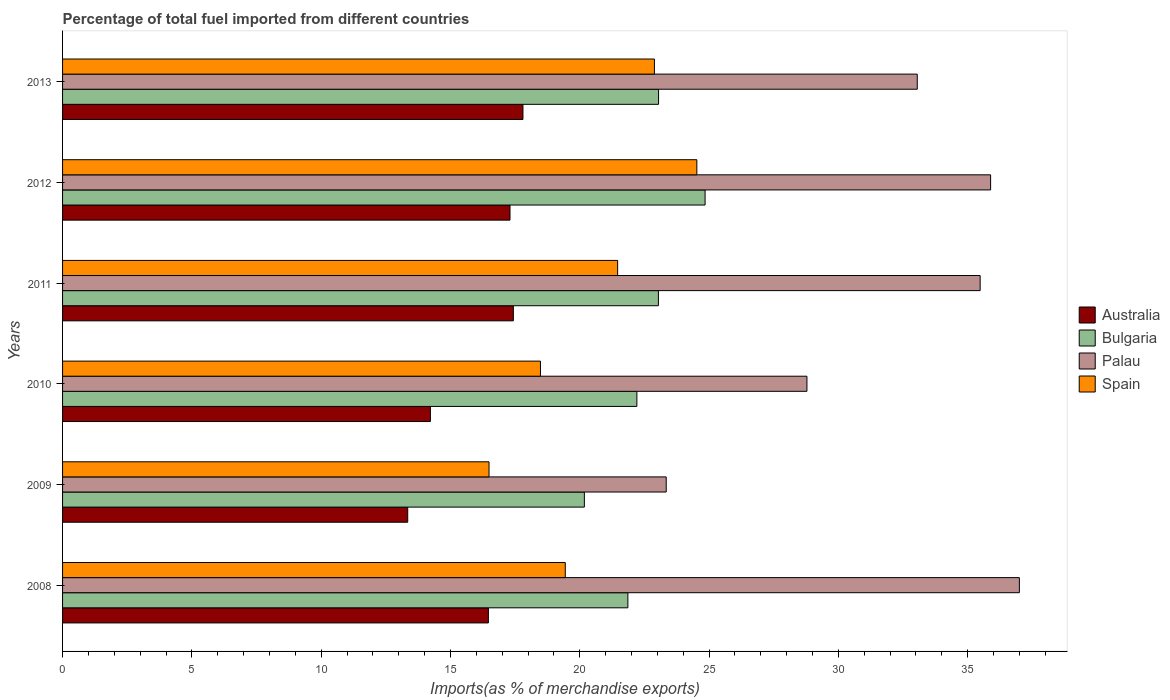Are the number of bars per tick equal to the number of legend labels?
Provide a short and direct response. Yes. Are the number of bars on each tick of the Y-axis equal?
Your response must be concise. Yes. How many bars are there on the 4th tick from the top?
Offer a terse response. 4. What is the percentage of imports to different countries in Spain in 2011?
Your response must be concise. 21.46. Across all years, what is the maximum percentage of imports to different countries in Australia?
Offer a very short reply. 17.8. Across all years, what is the minimum percentage of imports to different countries in Palau?
Offer a terse response. 23.34. In which year was the percentage of imports to different countries in Australia maximum?
Provide a short and direct response. 2013. In which year was the percentage of imports to different countries in Palau minimum?
Provide a succinct answer. 2009. What is the total percentage of imports to different countries in Bulgaria in the graph?
Keep it short and to the point. 135.18. What is the difference between the percentage of imports to different countries in Palau in 2008 and that in 2012?
Offer a very short reply. 1.11. What is the difference between the percentage of imports to different countries in Spain in 2010 and the percentage of imports to different countries in Bulgaria in 2011?
Give a very brief answer. -4.56. What is the average percentage of imports to different countries in Palau per year?
Your answer should be compact. 32.26. In the year 2012, what is the difference between the percentage of imports to different countries in Australia and percentage of imports to different countries in Spain?
Provide a short and direct response. -7.23. What is the ratio of the percentage of imports to different countries in Bulgaria in 2011 to that in 2012?
Provide a succinct answer. 0.93. Is the difference between the percentage of imports to different countries in Australia in 2009 and 2011 greater than the difference between the percentage of imports to different countries in Spain in 2009 and 2011?
Your answer should be very brief. Yes. What is the difference between the highest and the second highest percentage of imports to different countries in Australia?
Keep it short and to the point. 0.37. What is the difference between the highest and the lowest percentage of imports to different countries in Spain?
Offer a terse response. 8.04. In how many years, is the percentage of imports to different countries in Spain greater than the average percentage of imports to different countries in Spain taken over all years?
Offer a terse response. 3. Is the sum of the percentage of imports to different countries in Palau in 2010 and 2011 greater than the maximum percentage of imports to different countries in Bulgaria across all years?
Keep it short and to the point. Yes. Is it the case that in every year, the sum of the percentage of imports to different countries in Bulgaria and percentage of imports to different countries in Spain is greater than the sum of percentage of imports to different countries in Australia and percentage of imports to different countries in Palau?
Keep it short and to the point. No. Is it the case that in every year, the sum of the percentage of imports to different countries in Spain and percentage of imports to different countries in Australia is greater than the percentage of imports to different countries in Palau?
Your answer should be very brief. No. Are all the bars in the graph horizontal?
Make the answer very short. Yes. Are the values on the major ticks of X-axis written in scientific E-notation?
Your response must be concise. No. Where does the legend appear in the graph?
Your response must be concise. Center right. How are the legend labels stacked?
Ensure brevity in your answer.  Vertical. What is the title of the graph?
Your answer should be compact. Percentage of total fuel imported from different countries. Does "Sudan" appear as one of the legend labels in the graph?
Offer a terse response. No. What is the label or title of the X-axis?
Your answer should be compact. Imports(as % of merchandise exports). What is the label or title of the Y-axis?
Your answer should be compact. Years. What is the Imports(as % of merchandise exports) in Australia in 2008?
Keep it short and to the point. 16.47. What is the Imports(as % of merchandise exports) in Bulgaria in 2008?
Provide a succinct answer. 21.86. What is the Imports(as % of merchandise exports) in Palau in 2008?
Your response must be concise. 37. What is the Imports(as % of merchandise exports) in Spain in 2008?
Make the answer very short. 19.44. What is the Imports(as % of merchandise exports) in Australia in 2009?
Your answer should be very brief. 13.35. What is the Imports(as % of merchandise exports) in Bulgaria in 2009?
Offer a very short reply. 20.18. What is the Imports(as % of merchandise exports) of Palau in 2009?
Keep it short and to the point. 23.34. What is the Imports(as % of merchandise exports) in Spain in 2009?
Make the answer very short. 16.49. What is the Imports(as % of merchandise exports) in Australia in 2010?
Offer a very short reply. 14.22. What is the Imports(as % of merchandise exports) in Bulgaria in 2010?
Your answer should be compact. 22.21. What is the Imports(as % of merchandise exports) of Palau in 2010?
Your answer should be very brief. 28.78. What is the Imports(as % of merchandise exports) in Spain in 2010?
Provide a succinct answer. 18.48. What is the Imports(as % of merchandise exports) of Australia in 2011?
Keep it short and to the point. 17.43. What is the Imports(as % of merchandise exports) of Bulgaria in 2011?
Keep it short and to the point. 23.04. What is the Imports(as % of merchandise exports) in Palau in 2011?
Ensure brevity in your answer.  35.48. What is the Imports(as % of merchandise exports) in Spain in 2011?
Offer a terse response. 21.46. What is the Imports(as % of merchandise exports) of Australia in 2012?
Make the answer very short. 17.3. What is the Imports(as % of merchandise exports) in Bulgaria in 2012?
Ensure brevity in your answer.  24.85. What is the Imports(as % of merchandise exports) in Palau in 2012?
Offer a terse response. 35.89. What is the Imports(as % of merchandise exports) in Spain in 2012?
Your response must be concise. 24.53. What is the Imports(as % of merchandise exports) in Australia in 2013?
Provide a succinct answer. 17.8. What is the Imports(as % of merchandise exports) in Bulgaria in 2013?
Ensure brevity in your answer.  23.05. What is the Imports(as % of merchandise exports) in Palau in 2013?
Ensure brevity in your answer.  33.05. What is the Imports(as % of merchandise exports) in Spain in 2013?
Your answer should be very brief. 22.89. Across all years, what is the maximum Imports(as % of merchandise exports) in Australia?
Offer a very short reply. 17.8. Across all years, what is the maximum Imports(as % of merchandise exports) of Bulgaria?
Your response must be concise. 24.85. Across all years, what is the maximum Imports(as % of merchandise exports) in Palau?
Keep it short and to the point. 37. Across all years, what is the maximum Imports(as % of merchandise exports) of Spain?
Your answer should be compact. 24.53. Across all years, what is the minimum Imports(as % of merchandise exports) of Australia?
Give a very brief answer. 13.35. Across all years, what is the minimum Imports(as % of merchandise exports) of Bulgaria?
Make the answer very short. 20.18. Across all years, what is the minimum Imports(as % of merchandise exports) in Palau?
Give a very brief answer. 23.34. Across all years, what is the minimum Imports(as % of merchandise exports) of Spain?
Make the answer very short. 16.49. What is the total Imports(as % of merchandise exports) of Australia in the graph?
Offer a terse response. 96.57. What is the total Imports(as % of merchandise exports) in Bulgaria in the graph?
Your answer should be very brief. 135.18. What is the total Imports(as % of merchandise exports) of Palau in the graph?
Your response must be concise. 193.55. What is the total Imports(as % of merchandise exports) of Spain in the graph?
Offer a terse response. 123.29. What is the difference between the Imports(as % of merchandise exports) in Australia in 2008 and that in 2009?
Ensure brevity in your answer.  3.12. What is the difference between the Imports(as % of merchandise exports) of Bulgaria in 2008 and that in 2009?
Offer a terse response. 1.68. What is the difference between the Imports(as % of merchandise exports) in Palau in 2008 and that in 2009?
Offer a very short reply. 13.66. What is the difference between the Imports(as % of merchandise exports) of Spain in 2008 and that in 2009?
Provide a short and direct response. 2.95. What is the difference between the Imports(as % of merchandise exports) in Australia in 2008 and that in 2010?
Offer a very short reply. 2.24. What is the difference between the Imports(as % of merchandise exports) in Bulgaria in 2008 and that in 2010?
Keep it short and to the point. -0.35. What is the difference between the Imports(as % of merchandise exports) of Palau in 2008 and that in 2010?
Provide a succinct answer. 8.21. What is the difference between the Imports(as % of merchandise exports) in Spain in 2008 and that in 2010?
Keep it short and to the point. 0.96. What is the difference between the Imports(as % of merchandise exports) of Australia in 2008 and that in 2011?
Ensure brevity in your answer.  -0.97. What is the difference between the Imports(as % of merchandise exports) of Bulgaria in 2008 and that in 2011?
Your answer should be very brief. -1.18. What is the difference between the Imports(as % of merchandise exports) in Palau in 2008 and that in 2011?
Your answer should be very brief. 1.52. What is the difference between the Imports(as % of merchandise exports) of Spain in 2008 and that in 2011?
Provide a short and direct response. -2.03. What is the difference between the Imports(as % of merchandise exports) of Australia in 2008 and that in 2012?
Offer a terse response. -0.84. What is the difference between the Imports(as % of merchandise exports) of Bulgaria in 2008 and that in 2012?
Your answer should be very brief. -2.99. What is the difference between the Imports(as % of merchandise exports) in Palau in 2008 and that in 2012?
Offer a very short reply. 1.11. What is the difference between the Imports(as % of merchandise exports) in Spain in 2008 and that in 2012?
Give a very brief answer. -5.09. What is the difference between the Imports(as % of merchandise exports) in Australia in 2008 and that in 2013?
Your answer should be compact. -1.34. What is the difference between the Imports(as % of merchandise exports) of Bulgaria in 2008 and that in 2013?
Give a very brief answer. -1.19. What is the difference between the Imports(as % of merchandise exports) of Palau in 2008 and that in 2013?
Your answer should be very brief. 3.95. What is the difference between the Imports(as % of merchandise exports) of Spain in 2008 and that in 2013?
Your answer should be compact. -3.45. What is the difference between the Imports(as % of merchandise exports) of Australia in 2009 and that in 2010?
Your answer should be compact. -0.88. What is the difference between the Imports(as % of merchandise exports) in Bulgaria in 2009 and that in 2010?
Offer a very short reply. -2.03. What is the difference between the Imports(as % of merchandise exports) in Palau in 2009 and that in 2010?
Provide a short and direct response. -5.44. What is the difference between the Imports(as % of merchandise exports) of Spain in 2009 and that in 2010?
Offer a very short reply. -1.99. What is the difference between the Imports(as % of merchandise exports) in Australia in 2009 and that in 2011?
Offer a terse response. -4.09. What is the difference between the Imports(as % of merchandise exports) of Bulgaria in 2009 and that in 2011?
Offer a terse response. -2.86. What is the difference between the Imports(as % of merchandise exports) in Palau in 2009 and that in 2011?
Provide a succinct answer. -12.14. What is the difference between the Imports(as % of merchandise exports) of Spain in 2009 and that in 2011?
Provide a succinct answer. -4.97. What is the difference between the Imports(as % of merchandise exports) in Australia in 2009 and that in 2012?
Offer a terse response. -3.96. What is the difference between the Imports(as % of merchandise exports) of Bulgaria in 2009 and that in 2012?
Offer a very short reply. -4.67. What is the difference between the Imports(as % of merchandise exports) in Palau in 2009 and that in 2012?
Offer a terse response. -12.54. What is the difference between the Imports(as % of merchandise exports) of Spain in 2009 and that in 2012?
Keep it short and to the point. -8.04. What is the difference between the Imports(as % of merchandise exports) in Australia in 2009 and that in 2013?
Provide a short and direct response. -4.46. What is the difference between the Imports(as % of merchandise exports) in Bulgaria in 2009 and that in 2013?
Your answer should be very brief. -2.87. What is the difference between the Imports(as % of merchandise exports) in Palau in 2009 and that in 2013?
Keep it short and to the point. -9.71. What is the difference between the Imports(as % of merchandise exports) of Spain in 2009 and that in 2013?
Your response must be concise. -6.4. What is the difference between the Imports(as % of merchandise exports) of Australia in 2010 and that in 2011?
Your answer should be very brief. -3.21. What is the difference between the Imports(as % of merchandise exports) of Bulgaria in 2010 and that in 2011?
Your answer should be compact. -0.83. What is the difference between the Imports(as % of merchandise exports) in Palau in 2010 and that in 2011?
Keep it short and to the point. -6.7. What is the difference between the Imports(as % of merchandise exports) of Spain in 2010 and that in 2011?
Your answer should be compact. -2.98. What is the difference between the Imports(as % of merchandise exports) in Australia in 2010 and that in 2012?
Keep it short and to the point. -3.08. What is the difference between the Imports(as % of merchandise exports) in Bulgaria in 2010 and that in 2012?
Provide a succinct answer. -2.64. What is the difference between the Imports(as % of merchandise exports) in Palau in 2010 and that in 2012?
Your response must be concise. -7.1. What is the difference between the Imports(as % of merchandise exports) in Spain in 2010 and that in 2012?
Ensure brevity in your answer.  -6.05. What is the difference between the Imports(as % of merchandise exports) of Australia in 2010 and that in 2013?
Your response must be concise. -3.58. What is the difference between the Imports(as % of merchandise exports) in Bulgaria in 2010 and that in 2013?
Your answer should be compact. -0.84. What is the difference between the Imports(as % of merchandise exports) of Palau in 2010 and that in 2013?
Offer a terse response. -4.27. What is the difference between the Imports(as % of merchandise exports) in Spain in 2010 and that in 2013?
Keep it short and to the point. -4.41. What is the difference between the Imports(as % of merchandise exports) in Australia in 2011 and that in 2012?
Keep it short and to the point. 0.13. What is the difference between the Imports(as % of merchandise exports) in Bulgaria in 2011 and that in 2012?
Provide a short and direct response. -1.81. What is the difference between the Imports(as % of merchandise exports) in Palau in 2011 and that in 2012?
Give a very brief answer. -0.4. What is the difference between the Imports(as % of merchandise exports) in Spain in 2011 and that in 2012?
Your answer should be very brief. -3.06. What is the difference between the Imports(as % of merchandise exports) of Australia in 2011 and that in 2013?
Keep it short and to the point. -0.37. What is the difference between the Imports(as % of merchandise exports) in Bulgaria in 2011 and that in 2013?
Your answer should be very brief. -0.01. What is the difference between the Imports(as % of merchandise exports) of Palau in 2011 and that in 2013?
Provide a short and direct response. 2.43. What is the difference between the Imports(as % of merchandise exports) in Spain in 2011 and that in 2013?
Give a very brief answer. -1.42. What is the difference between the Imports(as % of merchandise exports) in Australia in 2012 and that in 2013?
Provide a succinct answer. -0.5. What is the difference between the Imports(as % of merchandise exports) of Bulgaria in 2012 and that in 2013?
Give a very brief answer. 1.8. What is the difference between the Imports(as % of merchandise exports) in Palau in 2012 and that in 2013?
Keep it short and to the point. 2.84. What is the difference between the Imports(as % of merchandise exports) in Spain in 2012 and that in 2013?
Ensure brevity in your answer.  1.64. What is the difference between the Imports(as % of merchandise exports) of Australia in 2008 and the Imports(as % of merchandise exports) of Bulgaria in 2009?
Provide a succinct answer. -3.71. What is the difference between the Imports(as % of merchandise exports) of Australia in 2008 and the Imports(as % of merchandise exports) of Palau in 2009?
Ensure brevity in your answer.  -6.88. What is the difference between the Imports(as % of merchandise exports) of Australia in 2008 and the Imports(as % of merchandise exports) of Spain in 2009?
Your answer should be very brief. -0.02. What is the difference between the Imports(as % of merchandise exports) in Bulgaria in 2008 and the Imports(as % of merchandise exports) in Palau in 2009?
Offer a terse response. -1.48. What is the difference between the Imports(as % of merchandise exports) of Bulgaria in 2008 and the Imports(as % of merchandise exports) of Spain in 2009?
Make the answer very short. 5.37. What is the difference between the Imports(as % of merchandise exports) in Palau in 2008 and the Imports(as % of merchandise exports) in Spain in 2009?
Your answer should be compact. 20.51. What is the difference between the Imports(as % of merchandise exports) in Australia in 2008 and the Imports(as % of merchandise exports) in Bulgaria in 2010?
Make the answer very short. -5.74. What is the difference between the Imports(as % of merchandise exports) in Australia in 2008 and the Imports(as % of merchandise exports) in Palau in 2010?
Ensure brevity in your answer.  -12.32. What is the difference between the Imports(as % of merchandise exports) of Australia in 2008 and the Imports(as % of merchandise exports) of Spain in 2010?
Your response must be concise. -2.01. What is the difference between the Imports(as % of merchandise exports) of Bulgaria in 2008 and the Imports(as % of merchandise exports) of Palau in 2010?
Your answer should be very brief. -6.92. What is the difference between the Imports(as % of merchandise exports) in Bulgaria in 2008 and the Imports(as % of merchandise exports) in Spain in 2010?
Offer a terse response. 3.38. What is the difference between the Imports(as % of merchandise exports) in Palau in 2008 and the Imports(as % of merchandise exports) in Spain in 2010?
Your answer should be compact. 18.52. What is the difference between the Imports(as % of merchandise exports) in Australia in 2008 and the Imports(as % of merchandise exports) in Bulgaria in 2011?
Offer a terse response. -6.57. What is the difference between the Imports(as % of merchandise exports) of Australia in 2008 and the Imports(as % of merchandise exports) of Palau in 2011?
Make the answer very short. -19.02. What is the difference between the Imports(as % of merchandise exports) in Australia in 2008 and the Imports(as % of merchandise exports) in Spain in 2011?
Give a very brief answer. -5. What is the difference between the Imports(as % of merchandise exports) in Bulgaria in 2008 and the Imports(as % of merchandise exports) in Palau in 2011?
Give a very brief answer. -13.62. What is the difference between the Imports(as % of merchandise exports) in Bulgaria in 2008 and the Imports(as % of merchandise exports) in Spain in 2011?
Keep it short and to the point. 0.4. What is the difference between the Imports(as % of merchandise exports) in Palau in 2008 and the Imports(as % of merchandise exports) in Spain in 2011?
Your response must be concise. 15.53. What is the difference between the Imports(as % of merchandise exports) in Australia in 2008 and the Imports(as % of merchandise exports) in Bulgaria in 2012?
Your answer should be compact. -8.38. What is the difference between the Imports(as % of merchandise exports) in Australia in 2008 and the Imports(as % of merchandise exports) in Palau in 2012?
Your answer should be compact. -19.42. What is the difference between the Imports(as % of merchandise exports) in Australia in 2008 and the Imports(as % of merchandise exports) in Spain in 2012?
Give a very brief answer. -8.06. What is the difference between the Imports(as % of merchandise exports) of Bulgaria in 2008 and the Imports(as % of merchandise exports) of Palau in 2012?
Make the answer very short. -14.03. What is the difference between the Imports(as % of merchandise exports) of Bulgaria in 2008 and the Imports(as % of merchandise exports) of Spain in 2012?
Your response must be concise. -2.67. What is the difference between the Imports(as % of merchandise exports) of Palau in 2008 and the Imports(as % of merchandise exports) of Spain in 2012?
Keep it short and to the point. 12.47. What is the difference between the Imports(as % of merchandise exports) in Australia in 2008 and the Imports(as % of merchandise exports) in Bulgaria in 2013?
Your answer should be very brief. -6.58. What is the difference between the Imports(as % of merchandise exports) in Australia in 2008 and the Imports(as % of merchandise exports) in Palau in 2013?
Keep it short and to the point. -16.58. What is the difference between the Imports(as % of merchandise exports) in Australia in 2008 and the Imports(as % of merchandise exports) in Spain in 2013?
Your response must be concise. -6.42. What is the difference between the Imports(as % of merchandise exports) of Bulgaria in 2008 and the Imports(as % of merchandise exports) of Palau in 2013?
Give a very brief answer. -11.19. What is the difference between the Imports(as % of merchandise exports) in Bulgaria in 2008 and the Imports(as % of merchandise exports) in Spain in 2013?
Give a very brief answer. -1.03. What is the difference between the Imports(as % of merchandise exports) in Palau in 2008 and the Imports(as % of merchandise exports) in Spain in 2013?
Keep it short and to the point. 14.11. What is the difference between the Imports(as % of merchandise exports) in Australia in 2009 and the Imports(as % of merchandise exports) in Bulgaria in 2010?
Your answer should be very brief. -8.86. What is the difference between the Imports(as % of merchandise exports) of Australia in 2009 and the Imports(as % of merchandise exports) of Palau in 2010?
Offer a terse response. -15.44. What is the difference between the Imports(as % of merchandise exports) of Australia in 2009 and the Imports(as % of merchandise exports) of Spain in 2010?
Give a very brief answer. -5.13. What is the difference between the Imports(as % of merchandise exports) in Bulgaria in 2009 and the Imports(as % of merchandise exports) in Palau in 2010?
Offer a very short reply. -8.61. What is the difference between the Imports(as % of merchandise exports) of Bulgaria in 2009 and the Imports(as % of merchandise exports) of Spain in 2010?
Provide a succinct answer. 1.7. What is the difference between the Imports(as % of merchandise exports) in Palau in 2009 and the Imports(as % of merchandise exports) in Spain in 2010?
Give a very brief answer. 4.86. What is the difference between the Imports(as % of merchandise exports) in Australia in 2009 and the Imports(as % of merchandise exports) in Bulgaria in 2011?
Make the answer very short. -9.69. What is the difference between the Imports(as % of merchandise exports) of Australia in 2009 and the Imports(as % of merchandise exports) of Palau in 2011?
Offer a very short reply. -22.14. What is the difference between the Imports(as % of merchandise exports) of Australia in 2009 and the Imports(as % of merchandise exports) of Spain in 2011?
Offer a terse response. -8.12. What is the difference between the Imports(as % of merchandise exports) of Bulgaria in 2009 and the Imports(as % of merchandise exports) of Palau in 2011?
Give a very brief answer. -15.31. What is the difference between the Imports(as % of merchandise exports) of Bulgaria in 2009 and the Imports(as % of merchandise exports) of Spain in 2011?
Keep it short and to the point. -1.29. What is the difference between the Imports(as % of merchandise exports) in Palau in 2009 and the Imports(as % of merchandise exports) in Spain in 2011?
Provide a short and direct response. 1.88. What is the difference between the Imports(as % of merchandise exports) in Australia in 2009 and the Imports(as % of merchandise exports) in Bulgaria in 2012?
Offer a very short reply. -11.5. What is the difference between the Imports(as % of merchandise exports) in Australia in 2009 and the Imports(as % of merchandise exports) in Palau in 2012?
Keep it short and to the point. -22.54. What is the difference between the Imports(as % of merchandise exports) in Australia in 2009 and the Imports(as % of merchandise exports) in Spain in 2012?
Keep it short and to the point. -11.18. What is the difference between the Imports(as % of merchandise exports) of Bulgaria in 2009 and the Imports(as % of merchandise exports) of Palau in 2012?
Ensure brevity in your answer.  -15.71. What is the difference between the Imports(as % of merchandise exports) of Bulgaria in 2009 and the Imports(as % of merchandise exports) of Spain in 2012?
Offer a very short reply. -4.35. What is the difference between the Imports(as % of merchandise exports) in Palau in 2009 and the Imports(as % of merchandise exports) in Spain in 2012?
Make the answer very short. -1.18. What is the difference between the Imports(as % of merchandise exports) in Australia in 2009 and the Imports(as % of merchandise exports) in Bulgaria in 2013?
Offer a very short reply. -9.7. What is the difference between the Imports(as % of merchandise exports) of Australia in 2009 and the Imports(as % of merchandise exports) of Palau in 2013?
Provide a short and direct response. -19.7. What is the difference between the Imports(as % of merchandise exports) of Australia in 2009 and the Imports(as % of merchandise exports) of Spain in 2013?
Your response must be concise. -9.54. What is the difference between the Imports(as % of merchandise exports) of Bulgaria in 2009 and the Imports(as % of merchandise exports) of Palau in 2013?
Your answer should be compact. -12.87. What is the difference between the Imports(as % of merchandise exports) of Bulgaria in 2009 and the Imports(as % of merchandise exports) of Spain in 2013?
Keep it short and to the point. -2.71. What is the difference between the Imports(as % of merchandise exports) of Palau in 2009 and the Imports(as % of merchandise exports) of Spain in 2013?
Ensure brevity in your answer.  0.46. What is the difference between the Imports(as % of merchandise exports) in Australia in 2010 and the Imports(as % of merchandise exports) in Bulgaria in 2011?
Keep it short and to the point. -8.82. What is the difference between the Imports(as % of merchandise exports) of Australia in 2010 and the Imports(as % of merchandise exports) of Palau in 2011?
Your answer should be compact. -21.26. What is the difference between the Imports(as % of merchandise exports) of Australia in 2010 and the Imports(as % of merchandise exports) of Spain in 2011?
Ensure brevity in your answer.  -7.24. What is the difference between the Imports(as % of merchandise exports) in Bulgaria in 2010 and the Imports(as % of merchandise exports) in Palau in 2011?
Give a very brief answer. -13.27. What is the difference between the Imports(as % of merchandise exports) of Bulgaria in 2010 and the Imports(as % of merchandise exports) of Spain in 2011?
Provide a short and direct response. 0.74. What is the difference between the Imports(as % of merchandise exports) in Palau in 2010 and the Imports(as % of merchandise exports) in Spain in 2011?
Give a very brief answer. 7.32. What is the difference between the Imports(as % of merchandise exports) in Australia in 2010 and the Imports(as % of merchandise exports) in Bulgaria in 2012?
Give a very brief answer. -10.62. What is the difference between the Imports(as % of merchandise exports) in Australia in 2010 and the Imports(as % of merchandise exports) in Palau in 2012?
Provide a succinct answer. -21.66. What is the difference between the Imports(as % of merchandise exports) in Australia in 2010 and the Imports(as % of merchandise exports) in Spain in 2012?
Provide a succinct answer. -10.3. What is the difference between the Imports(as % of merchandise exports) of Bulgaria in 2010 and the Imports(as % of merchandise exports) of Palau in 2012?
Offer a terse response. -13.68. What is the difference between the Imports(as % of merchandise exports) in Bulgaria in 2010 and the Imports(as % of merchandise exports) in Spain in 2012?
Give a very brief answer. -2.32. What is the difference between the Imports(as % of merchandise exports) of Palau in 2010 and the Imports(as % of merchandise exports) of Spain in 2012?
Provide a succinct answer. 4.26. What is the difference between the Imports(as % of merchandise exports) in Australia in 2010 and the Imports(as % of merchandise exports) in Bulgaria in 2013?
Your answer should be compact. -8.82. What is the difference between the Imports(as % of merchandise exports) of Australia in 2010 and the Imports(as % of merchandise exports) of Palau in 2013?
Provide a short and direct response. -18.83. What is the difference between the Imports(as % of merchandise exports) of Australia in 2010 and the Imports(as % of merchandise exports) of Spain in 2013?
Your response must be concise. -8.66. What is the difference between the Imports(as % of merchandise exports) in Bulgaria in 2010 and the Imports(as % of merchandise exports) in Palau in 2013?
Ensure brevity in your answer.  -10.84. What is the difference between the Imports(as % of merchandise exports) of Bulgaria in 2010 and the Imports(as % of merchandise exports) of Spain in 2013?
Ensure brevity in your answer.  -0.68. What is the difference between the Imports(as % of merchandise exports) in Palau in 2010 and the Imports(as % of merchandise exports) in Spain in 2013?
Your answer should be compact. 5.9. What is the difference between the Imports(as % of merchandise exports) of Australia in 2011 and the Imports(as % of merchandise exports) of Bulgaria in 2012?
Offer a terse response. -7.41. What is the difference between the Imports(as % of merchandise exports) of Australia in 2011 and the Imports(as % of merchandise exports) of Palau in 2012?
Offer a terse response. -18.46. What is the difference between the Imports(as % of merchandise exports) in Australia in 2011 and the Imports(as % of merchandise exports) in Spain in 2012?
Provide a succinct answer. -7.1. What is the difference between the Imports(as % of merchandise exports) in Bulgaria in 2011 and the Imports(as % of merchandise exports) in Palau in 2012?
Make the answer very short. -12.85. What is the difference between the Imports(as % of merchandise exports) in Bulgaria in 2011 and the Imports(as % of merchandise exports) in Spain in 2012?
Make the answer very short. -1.49. What is the difference between the Imports(as % of merchandise exports) of Palau in 2011 and the Imports(as % of merchandise exports) of Spain in 2012?
Provide a succinct answer. 10.96. What is the difference between the Imports(as % of merchandise exports) of Australia in 2011 and the Imports(as % of merchandise exports) of Bulgaria in 2013?
Provide a succinct answer. -5.62. What is the difference between the Imports(as % of merchandise exports) of Australia in 2011 and the Imports(as % of merchandise exports) of Palau in 2013?
Your answer should be very brief. -15.62. What is the difference between the Imports(as % of merchandise exports) of Australia in 2011 and the Imports(as % of merchandise exports) of Spain in 2013?
Your answer should be very brief. -5.45. What is the difference between the Imports(as % of merchandise exports) of Bulgaria in 2011 and the Imports(as % of merchandise exports) of Palau in 2013?
Make the answer very short. -10.01. What is the difference between the Imports(as % of merchandise exports) in Bulgaria in 2011 and the Imports(as % of merchandise exports) in Spain in 2013?
Keep it short and to the point. 0.15. What is the difference between the Imports(as % of merchandise exports) in Palau in 2011 and the Imports(as % of merchandise exports) in Spain in 2013?
Give a very brief answer. 12.6. What is the difference between the Imports(as % of merchandise exports) in Australia in 2012 and the Imports(as % of merchandise exports) in Bulgaria in 2013?
Your answer should be very brief. -5.75. What is the difference between the Imports(as % of merchandise exports) of Australia in 2012 and the Imports(as % of merchandise exports) of Palau in 2013?
Offer a terse response. -15.75. What is the difference between the Imports(as % of merchandise exports) of Australia in 2012 and the Imports(as % of merchandise exports) of Spain in 2013?
Provide a short and direct response. -5.58. What is the difference between the Imports(as % of merchandise exports) in Bulgaria in 2012 and the Imports(as % of merchandise exports) in Palau in 2013?
Ensure brevity in your answer.  -8.2. What is the difference between the Imports(as % of merchandise exports) in Bulgaria in 2012 and the Imports(as % of merchandise exports) in Spain in 2013?
Your response must be concise. 1.96. What is the difference between the Imports(as % of merchandise exports) of Palau in 2012 and the Imports(as % of merchandise exports) of Spain in 2013?
Ensure brevity in your answer.  13. What is the average Imports(as % of merchandise exports) in Australia per year?
Give a very brief answer. 16.1. What is the average Imports(as % of merchandise exports) of Bulgaria per year?
Your response must be concise. 22.53. What is the average Imports(as % of merchandise exports) in Palau per year?
Keep it short and to the point. 32.26. What is the average Imports(as % of merchandise exports) in Spain per year?
Offer a very short reply. 20.55. In the year 2008, what is the difference between the Imports(as % of merchandise exports) in Australia and Imports(as % of merchandise exports) in Bulgaria?
Provide a short and direct response. -5.39. In the year 2008, what is the difference between the Imports(as % of merchandise exports) in Australia and Imports(as % of merchandise exports) in Palau?
Your response must be concise. -20.53. In the year 2008, what is the difference between the Imports(as % of merchandise exports) in Australia and Imports(as % of merchandise exports) in Spain?
Keep it short and to the point. -2.97. In the year 2008, what is the difference between the Imports(as % of merchandise exports) of Bulgaria and Imports(as % of merchandise exports) of Palau?
Your response must be concise. -15.14. In the year 2008, what is the difference between the Imports(as % of merchandise exports) of Bulgaria and Imports(as % of merchandise exports) of Spain?
Your answer should be very brief. 2.42. In the year 2008, what is the difference between the Imports(as % of merchandise exports) of Palau and Imports(as % of merchandise exports) of Spain?
Offer a very short reply. 17.56. In the year 2009, what is the difference between the Imports(as % of merchandise exports) of Australia and Imports(as % of merchandise exports) of Bulgaria?
Make the answer very short. -6.83. In the year 2009, what is the difference between the Imports(as % of merchandise exports) of Australia and Imports(as % of merchandise exports) of Palau?
Give a very brief answer. -10. In the year 2009, what is the difference between the Imports(as % of merchandise exports) of Australia and Imports(as % of merchandise exports) of Spain?
Your answer should be very brief. -3.14. In the year 2009, what is the difference between the Imports(as % of merchandise exports) of Bulgaria and Imports(as % of merchandise exports) of Palau?
Your response must be concise. -3.17. In the year 2009, what is the difference between the Imports(as % of merchandise exports) of Bulgaria and Imports(as % of merchandise exports) of Spain?
Your answer should be very brief. 3.69. In the year 2009, what is the difference between the Imports(as % of merchandise exports) in Palau and Imports(as % of merchandise exports) in Spain?
Keep it short and to the point. 6.85. In the year 2010, what is the difference between the Imports(as % of merchandise exports) in Australia and Imports(as % of merchandise exports) in Bulgaria?
Your answer should be very brief. -7.98. In the year 2010, what is the difference between the Imports(as % of merchandise exports) in Australia and Imports(as % of merchandise exports) in Palau?
Provide a succinct answer. -14.56. In the year 2010, what is the difference between the Imports(as % of merchandise exports) in Australia and Imports(as % of merchandise exports) in Spain?
Your answer should be very brief. -4.26. In the year 2010, what is the difference between the Imports(as % of merchandise exports) in Bulgaria and Imports(as % of merchandise exports) in Palau?
Give a very brief answer. -6.58. In the year 2010, what is the difference between the Imports(as % of merchandise exports) in Bulgaria and Imports(as % of merchandise exports) in Spain?
Your answer should be very brief. 3.73. In the year 2010, what is the difference between the Imports(as % of merchandise exports) of Palau and Imports(as % of merchandise exports) of Spain?
Offer a very short reply. 10.3. In the year 2011, what is the difference between the Imports(as % of merchandise exports) in Australia and Imports(as % of merchandise exports) in Bulgaria?
Your answer should be very brief. -5.61. In the year 2011, what is the difference between the Imports(as % of merchandise exports) in Australia and Imports(as % of merchandise exports) in Palau?
Offer a terse response. -18.05. In the year 2011, what is the difference between the Imports(as % of merchandise exports) of Australia and Imports(as % of merchandise exports) of Spain?
Ensure brevity in your answer.  -4.03. In the year 2011, what is the difference between the Imports(as % of merchandise exports) of Bulgaria and Imports(as % of merchandise exports) of Palau?
Offer a very short reply. -12.44. In the year 2011, what is the difference between the Imports(as % of merchandise exports) in Bulgaria and Imports(as % of merchandise exports) in Spain?
Ensure brevity in your answer.  1.58. In the year 2011, what is the difference between the Imports(as % of merchandise exports) of Palau and Imports(as % of merchandise exports) of Spain?
Ensure brevity in your answer.  14.02. In the year 2012, what is the difference between the Imports(as % of merchandise exports) in Australia and Imports(as % of merchandise exports) in Bulgaria?
Make the answer very short. -7.54. In the year 2012, what is the difference between the Imports(as % of merchandise exports) in Australia and Imports(as % of merchandise exports) in Palau?
Provide a short and direct response. -18.59. In the year 2012, what is the difference between the Imports(as % of merchandise exports) in Australia and Imports(as % of merchandise exports) in Spain?
Keep it short and to the point. -7.23. In the year 2012, what is the difference between the Imports(as % of merchandise exports) of Bulgaria and Imports(as % of merchandise exports) of Palau?
Your answer should be compact. -11.04. In the year 2012, what is the difference between the Imports(as % of merchandise exports) in Bulgaria and Imports(as % of merchandise exports) in Spain?
Your answer should be compact. 0.32. In the year 2012, what is the difference between the Imports(as % of merchandise exports) in Palau and Imports(as % of merchandise exports) in Spain?
Offer a terse response. 11.36. In the year 2013, what is the difference between the Imports(as % of merchandise exports) of Australia and Imports(as % of merchandise exports) of Bulgaria?
Provide a short and direct response. -5.24. In the year 2013, what is the difference between the Imports(as % of merchandise exports) of Australia and Imports(as % of merchandise exports) of Palau?
Provide a short and direct response. -15.25. In the year 2013, what is the difference between the Imports(as % of merchandise exports) in Australia and Imports(as % of merchandise exports) in Spain?
Make the answer very short. -5.08. In the year 2013, what is the difference between the Imports(as % of merchandise exports) in Bulgaria and Imports(as % of merchandise exports) in Palau?
Your answer should be very brief. -10. In the year 2013, what is the difference between the Imports(as % of merchandise exports) in Bulgaria and Imports(as % of merchandise exports) in Spain?
Your answer should be very brief. 0.16. In the year 2013, what is the difference between the Imports(as % of merchandise exports) of Palau and Imports(as % of merchandise exports) of Spain?
Give a very brief answer. 10.16. What is the ratio of the Imports(as % of merchandise exports) in Australia in 2008 to that in 2009?
Offer a terse response. 1.23. What is the ratio of the Imports(as % of merchandise exports) in Bulgaria in 2008 to that in 2009?
Give a very brief answer. 1.08. What is the ratio of the Imports(as % of merchandise exports) of Palau in 2008 to that in 2009?
Your response must be concise. 1.58. What is the ratio of the Imports(as % of merchandise exports) of Spain in 2008 to that in 2009?
Your answer should be very brief. 1.18. What is the ratio of the Imports(as % of merchandise exports) of Australia in 2008 to that in 2010?
Offer a terse response. 1.16. What is the ratio of the Imports(as % of merchandise exports) of Bulgaria in 2008 to that in 2010?
Provide a succinct answer. 0.98. What is the ratio of the Imports(as % of merchandise exports) in Palau in 2008 to that in 2010?
Provide a short and direct response. 1.29. What is the ratio of the Imports(as % of merchandise exports) of Spain in 2008 to that in 2010?
Keep it short and to the point. 1.05. What is the ratio of the Imports(as % of merchandise exports) of Australia in 2008 to that in 2011?
Your response must be concise. 0.94. What is the ratio of the Imports(as % of merchandise exports) of Bulgaria in 2008 to that in 2011?
Provide a succinct answer. 0.95. What is the ratio of the Imports(as % of merchandise exports) of Palau in 2008 to that in 2011?
Offer a terse response. 1.04. What is the ratio of the Imports(as % of merchandise exports) in Spain in 2008 to that in 2011?
Give a very brief answer. 0.91. What is the ratio of the Imports(as % of merchandise exports) of Australia in 2008 to that in 2012?
Your answer should be very brief. 0.95. What is the ratio of the Imports(as % of merchandise exports) in Bulgaria in 2008 to that in 2012?
Provide a succinct answer. 0.88. What is the ratio of the Imports(as % of merchandise exports) in Palau in 2008 to that in 2012?
Your response must be concise. 1.03. What is the ratio of the Imports(as % of merchandise exports) of Spain in 2008 to that in 2012?
Provide a succinct answer. 0.79. What is the ratio of the Imports(as % of merchandise exports) in Australia in 2008 to that in 2013?
Offer a terse response. 0.92. What is the ratio of the Imports(as % of merchandise exports) of Bulgaria in 2008 to that in 2013?
Give a very brief answer. 0.95. What is the ratio of the Imports(as % of merchandise exports) in Palau in 2008 to that in 2013?
Offer a terse response. 1.12. What is the ratio of the Imports(as % of merchandise exports) in Spain in 2008 to that in 2013?
Provide a succinct answer. 0.85. What is the ratio of the Imports(as % of merchandise exports) in Australia in 2009 to that in 2010?
Offer a terse response. 0.94. What is the ratio of the Imports(as % of merchandise exports) of Bulgaria in 2009 to that in 2010?
Provide a succinct answer. 0.91. What is the ratio of the Imports(as % of merchandise exports) in Palau in 2009 to that in 2010?
Your response must be concise. 0.81. What is the ratio of the Imports(as % of merchandise exports) of Spain in 2009 to that in 2010?
Your answer should be very brief. 0.89. What is the ratio of the Imports(as % of merchandise exports) of Australia in 2009 to that in 2011?
Make the answer very short. 0.77. What is the ratio of the Imports(as % of merchandise exports) in Bulgaria in 2009 to that in 2011?
Your answer should be very brief. 0.88. What is the ratio of the Imports(as % of merchandise exports) in Palau in 2009 to that in 2011?
Keep it short and to the point. 0.66. What is the ratio of the Imports(as % of merchandise exports) in Spain in 2009 to that in 2011?
Offer a terse response. 0.77. What is the ratio of the Imports(as % of merchandise exports) in Australia in 2009 to that in 2012?
Provide a succinct answer. 0.77. What is the ratio of the Imports(as % of merchandise exports) in Bulgaria in 2009 to that in 2012?
Provide a succinct answer. 0.81. What is the ratio of the Imports(as % of merchandise exports) of Palau in 2009 to that in 2012?
Offer a very short reply. 0.65. What is the ratio of the Imports(as % of merchandise exports) in Spain in 2009 to that in 2012?
Make the answer very short. 0.67. What is the ratio of the Imports(as % of merchandise exports) in Australia in 2009 to that in 2013?
Your answer should be compact. 0.75. What is the ratio of the Imports(as % of merchandise exports) of Bulgaria in 2009 to that in 2013?
Your answer should be very brief. 0.88. What is the ratio of the Imports(as % of merchandise exports) of Palau in 2009 to that in 2013?
Give a very brief answer. 0.71. What is the ratio of the Imports(as % of merchandise exports) in Spain in 2009 to that in 2013?
Your response must be concise. 0.72. What is the ratio of the Imports(as % of merchandise exports) of Australia in 2010 to that in 2011?
Provide a succinct answer. 0.82. What is the ratio of the Imports(as % of merchandise exports) of Bulgaria in 2010 to that in 2011?
Ensure brevity in your answer.  0.96. What is the ratio of the Imports(as % of merchandise exports) of Palau in 2010 to that in 2011?
Ensure brevity in your answer.  0.81. What is the ratio of the Imports(as % of merchandise exports) of Spain in 2010 to that in 2011?
Provide a succinct answer. 0.86. What is the ratio of the Imports(as % of merchandise exports) in Australia in 2010 to that in 2012?
Offer a terse response. 0.82. What is the ratio of the Imports(as % of merchandise exports) in Bulgaria in 2010 to that in 2012?
Ensure brevity in your answer.  0.89. What is the ratio of the Imports(as % of merchandise exports) in Palau in 2010 to that in 2012?
Offer a terse response. 0.8. What is the ratio of the Imports(as % of merchandise exports) in Spain in 2010 to that in 2012?
Make the answer very short. 0.75. What is the ratio of the Imports(as % of merchandise exports) in Australia in 2010 to that in 2013?
Provide a succinct answer. 0.8. What is the ratio of the Imports(as % of merchandise exports) of Bulgaria in 2010 to that in 2013?
Provide a short and direct response. 0.96. What is the ratio of the Imports(as % of merchandise exports) of Palau in 2010 to that in 2013?
Give a very brief answer. 0.87. What is the ratio of the Imports(as % of merchandise exports) of Spain in 2010 to that in 2013?
Your answer should be compact. 0.81. What is the ratio of the Imports(as % of merchandise exports) in Australia in 2011 to that in 2012?
Ensure brevity in your answer.  1.01. What is the ratio of the Imports(as % of merchandise exports) of Bulgaria in 2011 to that in 2012?
Offer a very short reply. 0.93. What is the ratio of the Imports(as % of merchandise exports) of Palau in 2011 to that in 2012?
Your answer should be compact. 0.99. What is the ratio of the Imports(as % of merchandise exports) of Spain in 2011 to that in 2012?
Your response must be concise. 0.88. What is the ratio of the Imports(as % of merchandise exports) in Australia in 2011 to that in 2013?
Keep it short and to the point. 0.98. What is the ratio of the Imports(as % of merchandise exports) in Palau in 2011 to that in 2013?
Your answer should be very brief. 1.07. What is the ratio of the Imports(as % of merchandise exports) in Spain in 2011 to that in 2013?
Provide a succinct answer. 0.94. What is the ratio of the Imports(as % of merchandise exports) in Australia in 2012 to that in 2013?
Your answer should be compact. 0.97. What is the ratio of the Imports(as % of merchandise exports) of Bulgaria in 2012 to that in 2013?
Provide a succinct answer. 1.08. What is the ratio of the Imports(as % of merchandise exports) of Palau in 2012 to that in 2013?
Provide a short and direct response. 1.09. What is the ratio of the Imports(as % of merchandise exports) of Spain in 2012 to that in 2013?
Your response must be concise. 1.07. What is the difference between the highest and the second highest Imports(as % of merchandise exports) in Australia?
Your answer should be very brief. 0.37. What is the difference between the highest and the second highest Imports(as % of merchandise exports) of Bulgaria?
Keep it short and to the point. 1.8. What is the difference between the highest and the second highest Imports(as % of merchandise exports) in Palau?
Offer a very short reply. 1.11. What is the difference between the highest and the second highest Imports(as % of merchandise exports) in Spain?
Your answer should be compact. 1.64. What is the difference between the highest and the lowest Imports(as % of merchandise exports) of Australia?
Provide a succinct answer. 4.46. What is the difference between the highest and the lowest Imports(as % of merchandise exports) in Bulgaria?
Your answer should be very brief. 4.67. What is the difference between the highest and the lowest Imports(as % of merchandise exports) of Palau?
Offer a terse response. 13.66. What is the difference between the highest and the lowest Imports(as % of merchandise exports) of Spain?
Provide a succinct answer. 8.04. 